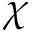Convert formula to latex. <formula><loc_0><loc_0><loc_500><loc_500>\chi</formula> 